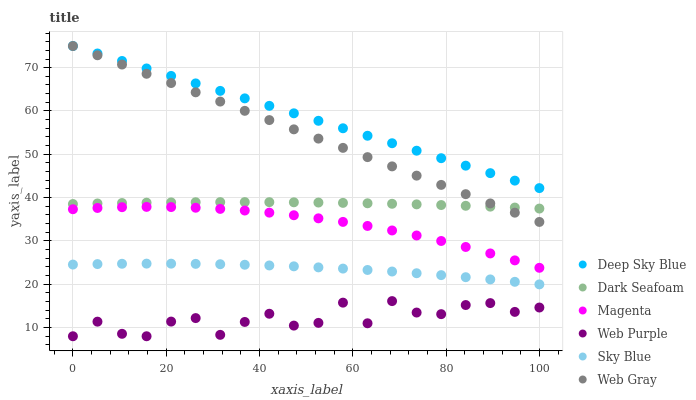Does Web Purple have the minimum area under the curve?
Answer yes or no. Yes. Does Deep Sky Blue have the maximum area under the curve?
Answer yes or no. Yes. Does Dark Seafoam have the minimum area under the curve?
Answer yes or no. No. Does Dark Seafoam have the maximum area under the curve?
Answer yes or no. No. Is Web Gray the smoothest?
Answer yes or no. Yes. Is Web Purple the roughest?
Answer yes or no. Yes. Is Dark Seafoam the smoothest?
Answer yes or no. No. Is Dark Seafoam the roughest?
Answer yes or no. No. Does Web Purple have the lowest value?
Answer yes or no. Yes. Does Dark Seafoam have the lowest value?
Answer yes or no. No. Does Deep Sky Blue have the highest value?
Answer yes or no. Yes. Does Dark Seafoam have the highest value?
Answer yes or no. No. Is Sky Blue less than Magenta?
Answer yes or no. Yes. Is Dark Seafoam greater than Sky Blue?
Answer yes or no. Yes. Does Web Gray intersect Deep Sky Blue?
Answer yes or no. Yes. Is Web Gray less than Deep Sky Blue?
Answer yes or no. No. Is Web Gray greater than Deep Sky Blue?
Answer yes or no. No. Does Sky Blue intersect Magenta?
Answer yes or no. No. 